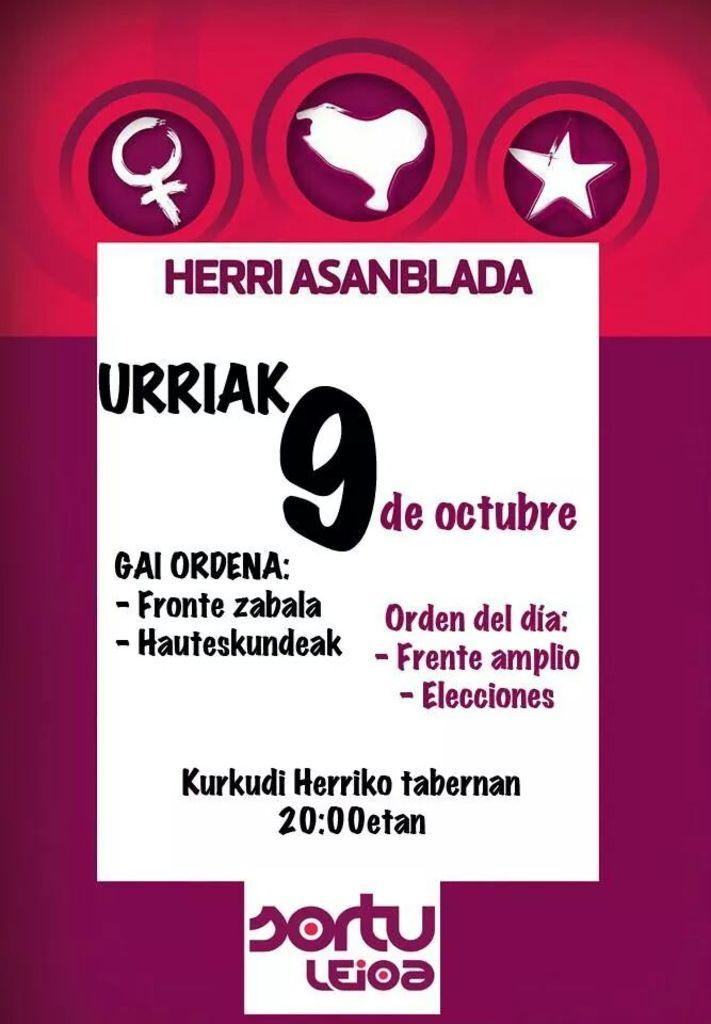What is the main subject of the picture? The main subject of the picture is a graphic image. What is featured in the center of the graphic image? There is text in the middle of the graphic image. What else can be seen in the graphic image besides the text? There are icons above the text. How many bikes are parked next to the graphic image? There are no bikes present in the image; it only features a graphic image with text and icons. What type of shoe is shown in the graphic image? There is no shoe depicted in the graphic image; it only contains text and icons. 